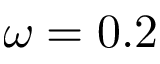Convert formula to latex. <formula><loc_0><loc_0><loc_500><loc_500>\omega = 0 . 2</formula> 